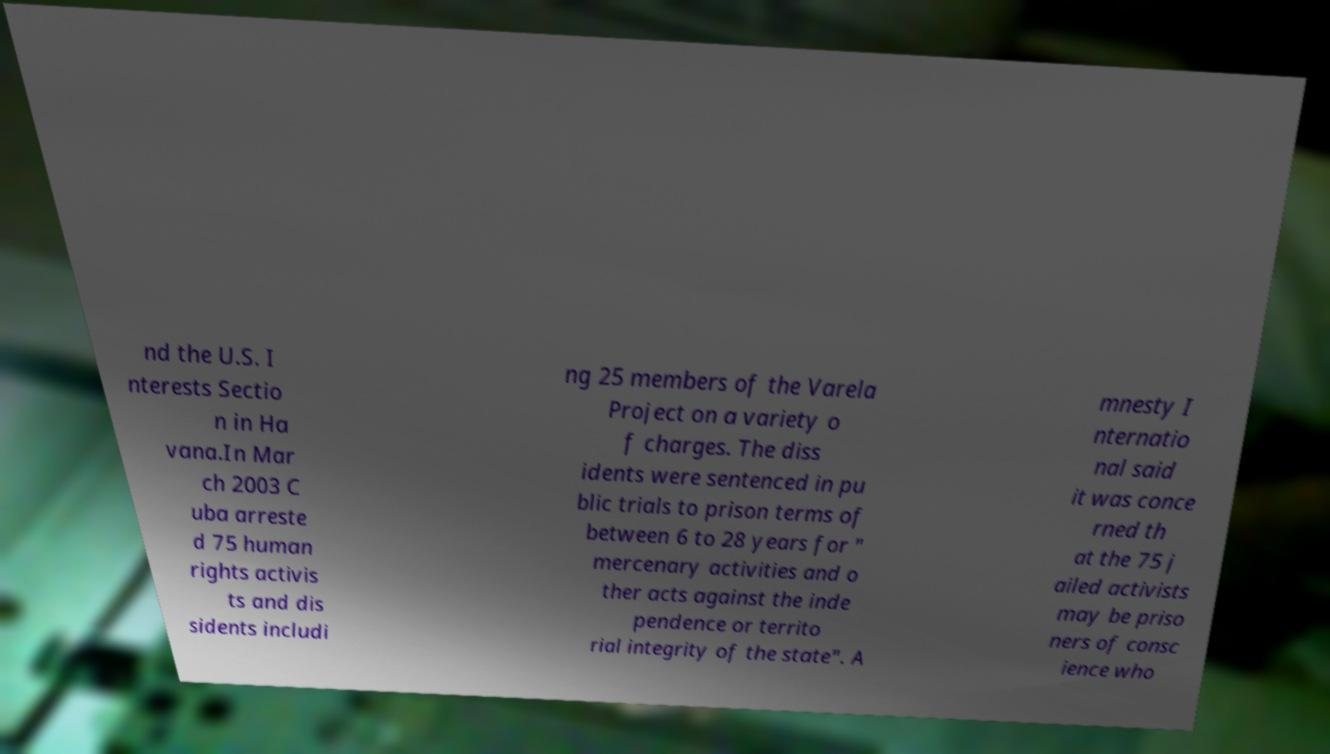There's text embedded in this image that I need extracted. Can you transcribe it verbatim? nd the U.S. I nterests Sectio n in Ha vana.In Mar ch 2003 C uba arreste d 75 human rights activis ts and dis sidents includi ng 25 members of the Varela Project on a variety o f charges. The diss idents were sentenced in pu blic trials to prison terms of between 6 to 28 years for " mercenary activities and o ther acts against the inde pendence or territo rial integrity of the state". A mnesty I nternatio nal said it was conce rned th at the 75 j ailed activists may be priso ners of consc ience who 